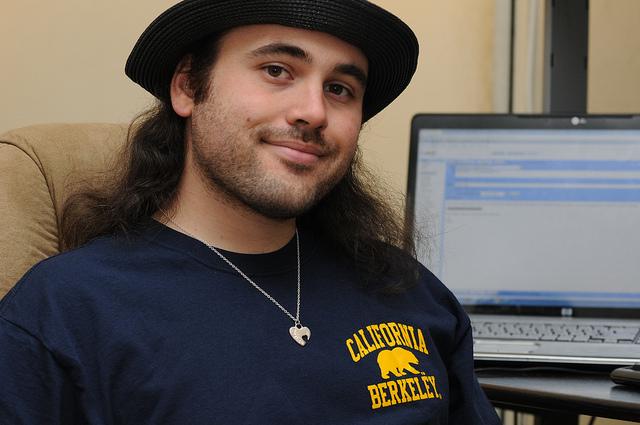What is the pendant on his necklace?
Short answer required. Heart. What uniforms are shown?
Concise answer only. California berkeley. What is the on the man's face?
Concise answer only. Beard. Is the man wearing a hat?
Answer briefly. Yes. Is he wearing a nametag?
Short answer required. No. Is he wearing a hat?
Concise answer only. Yes. What does the man's shirt say?
Answer briefly. California berkeley. What type of hat is he wearing?
Concise answer only. Fedora. What is the college name on his shirt?
Answer briefly. Berkeley. Is the man wearing a tie?
Short answer required. No. What sports team is depicted here?
Quick response, please. California berkeley. What school does this guy like?
Quick response, please. California berkeley. What US state is written on the man's shirt?
Keep it brief. California. Was this picture likely taken in 2015?
Short answer required. Yes. What animal is on this person's t shirt?
Answer briefly. Bear. 